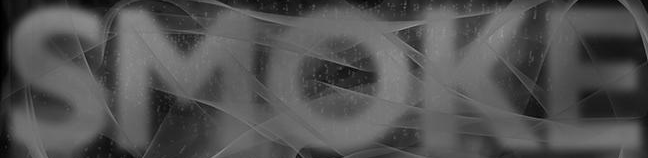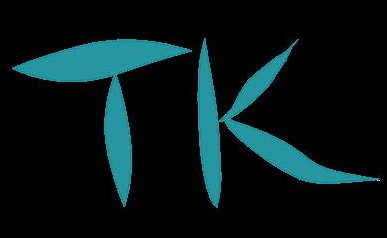What words are shown in these images in order, separated by a semicolon? SMOKE; TK 